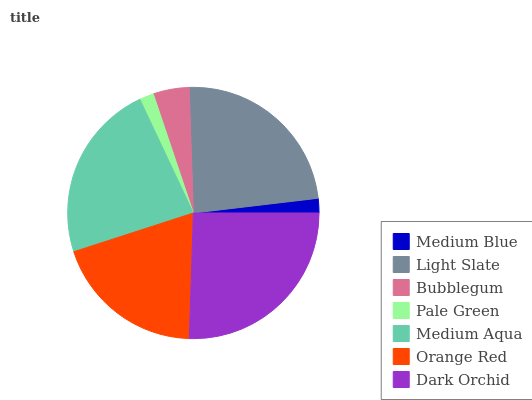Is Pale Green the minimum?
Answer yes or no. Yes. Is Dark Orchid the maximum?
Answer yes or no. Yes. Is Light Slate the minimum?
Answer yes or no. No. Is Light Slate the maximum?
Answer yes or no. No. Is Light Slate greater than Medium Blue?
Answer yes or no. Yes. Is Medium Blue less than Light Slate?
Answer yes or no. Yes. Is Medium Blue greater than Light Slate?
Answer yes or no. No. Is Light Slate less than Medium Blue?
Answer yes or no. No. Is Orange Red the high median?
Answer yes or no. Yes. Is Orange Red the low median?
Answer yes or no. Yes. Is Pale Green the high median?
Answer yes or no. No. Is Dark Orchid the low median?
Answer yes or no. No. 